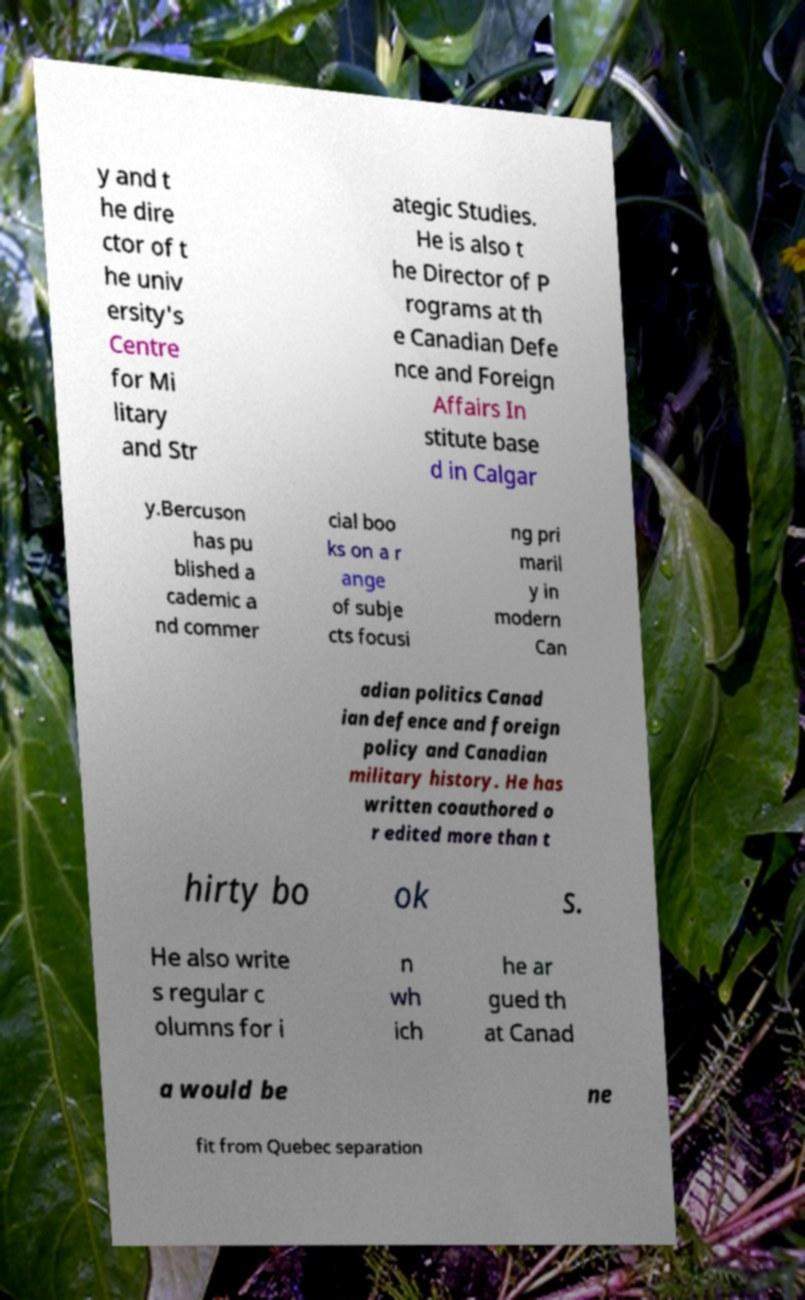Please identify and transcribe the text found in this image. y and t he dire ctor of t he univ ersity's Centre for Mi litary and Str ategic Studies. He is also t he Director of P rograms at th e Canadian Defe nce and Foreign Affairs In stitute base d in Calgar y.Bercuson has pu blished a cademic a nd commer cial boo ks on a r ange of subje cts focusi ng pri maril y in modern Can adian politics Canad ian defence and foreign policy and Canadian military history. He has written coauthored o r edited more than t hirty bo ok s. He also write s regular c olumns for i n wh ich he ar gued th at Canad a would be ne fit from Quebec separation 